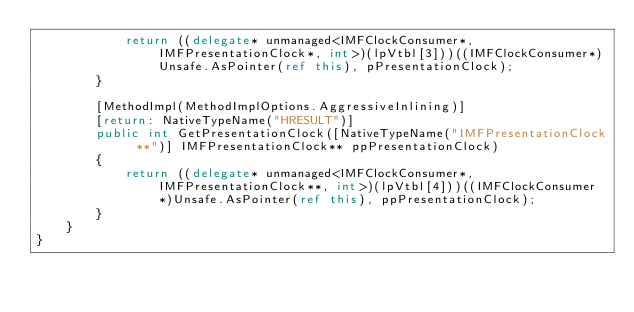<code> <loc_0><loc_0><loc_500><loc_500><_C#_>            return ((delegate* unmanaged<IMFClockConsumer*, IMFPresentationClock*, int>)(lpVtbl[3]))((IMFClockConsumer*)Unsafe.AsPointer(ref this), pPresentationClock);
        }

        [MethodImpl(MethodImplOptions.AggressiveInlining)]
        [return: NativeTypeName("HRESULT")]
        public int GetPresentationClock([NativeTypeName("IMFPresentationClock **")] IMFPresentationClock** ppPresentationClock)
        {
            return ((delegate* unmanaged<IMFClockConsumer*, IMFPresentationClock**, int>)(lpVtbl[4]))((IMFClockConsumer*)Unsafe.AsPointer(ref this), ppPresentationClock);
        }
    }
}
</code> 